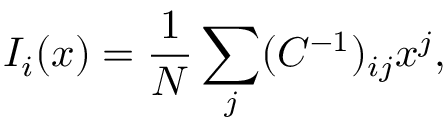<formula> <loc_0><loc_0><loc_500><loc_500>I _ { i } ( x ) = \frac { 1 } { N } \sum _ { j } ( C ^ { - 1 } ) _ { i j } x ^ { j } ,</formula> 